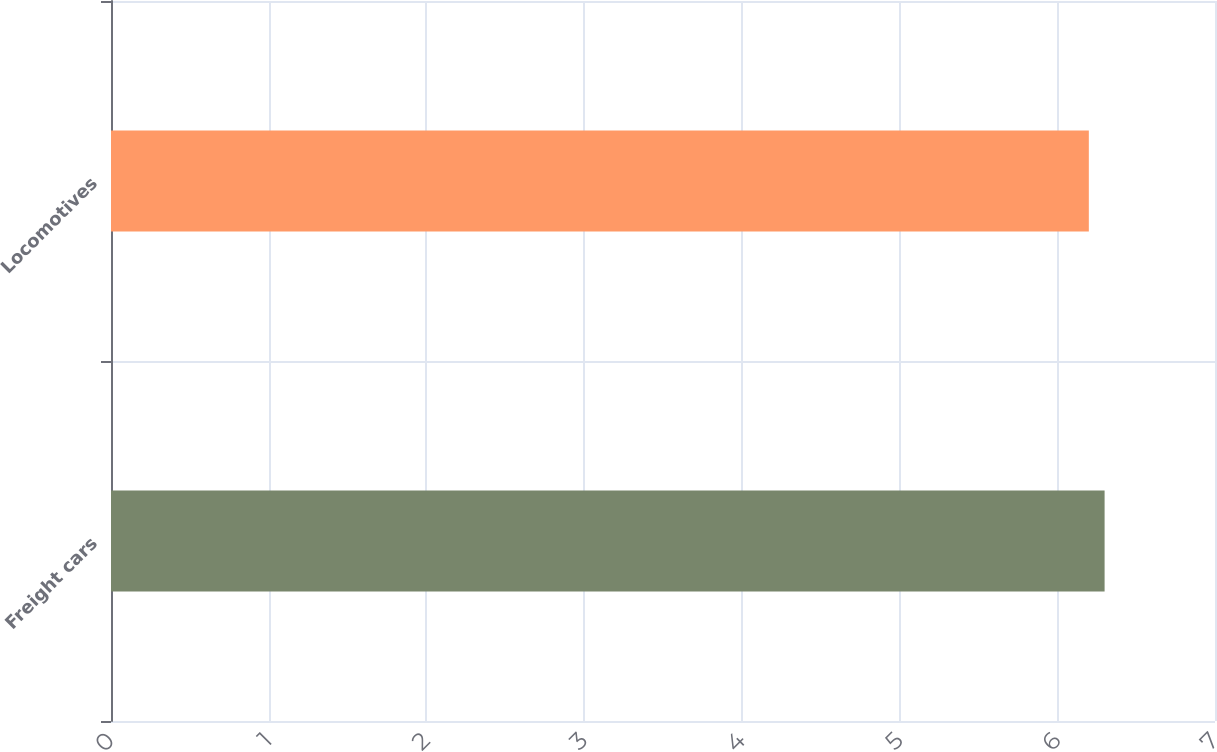Convert chart to OTSL. <chart><loc_0><loc_0><loc_500><loc_500><bar_chart><fcel>Freight cars<fcel>Locomotives<nl><fcel>6.3<fcel>6.2<nl></chart> 